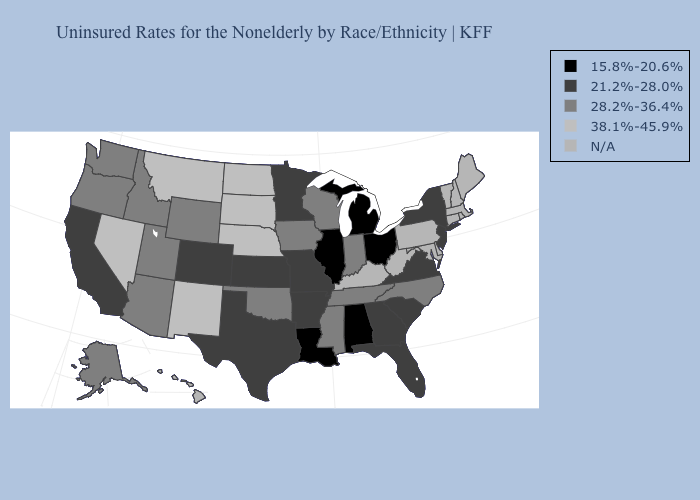Which states hav the highest value in the Northeast?
Write a very short answer. New Jersey, New York. Name the states that have a value in the range 15.8%-20.6%?
Give a very brief answer. Alabama, Illinois, Louisiana, Michigan, Ohio. Does Indiana have the highest value in the USA?
Concise answer only. No. What is the highest value in the South ?
Keep it brief. 28.2%-36.4%. Among the states that border Pennsylvania , which have the highest value?
Answer briefly. New Jersey, New York. Is the legend a continuous bar?
Keep it brief. No. Name the states that have a value in the range 38.1%-45.9%?
Concise answer only. Montana, Nebraska, Nevada, New Mexico, North Dakota, South Dakota. Which states have the lowest value in the Northeast?
Concise answer only. New Jersey, New York. Name the states that have a value in the range 28.2%-36.4%?
Answer briefly. Alaska, Arizona, Idaho, Indiana, Iowa, Mississippi, North Carolina, Oklahoma, Oregon, Tennessee, Utah, Washington, Wisconsin, Wyoming. What is the value of Virginia?
Quick response, please. 21.2%-28.0%. What is the lowest value in states that border Kansas?
Keep it brief. 21.2%-28.0%. Name the states that have a value in the range N/A?
Write a very short answer. Connecticut, Delaware, Hawaii, Kentucky, Maine, Maryland, Massachusetts, New Hampshire, Pennsylvania, Rhode Island, Vermont, West Virginia. Among the states that border West Virginia , does Virginia have the highest value?
Give a very brief answer. Yes. What is the value of Virginia?
Quick response, please. 21.2%-28.0%. Does the first symbol in the legend represent the smallest category?
Concise answer only. Yes. 